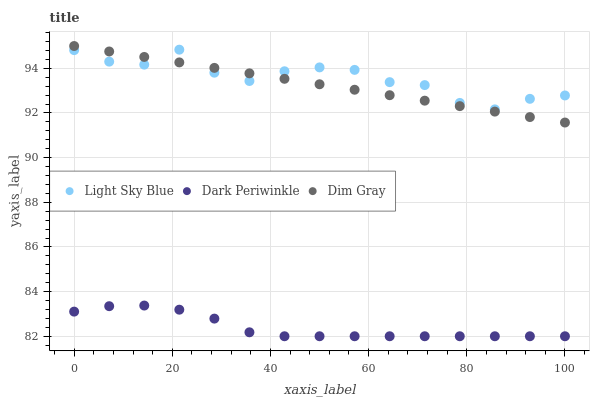Does Dark Periwinkle have the minimum area under the curve?
Answer yes or no. Yes. Does Light Sky Blue have the maximum area under the curve?
Answer yes or no. Yes. Does Light Sky Blue have the minimum area under the curve?
Answer yes or no. No. Does Dark Periwinkle have the maximum area under the curve?
Answer yes or no. No. Is Dim Gray the smoothest?
Answer yes or no. Yes. Is Light Sky Blue the roughest?
Answer yes or no. Yes. Is Dark Periwinkle the smoothest?
Answer yes or no. No. Is Dark Periwinkle the roughest?
Answer yes or no. No. Does Dark Periwinkle have the lowest value?
Answer yes or no. Yes. Does Light Sky Blue have the lowest value?
Answer yes or no. No. Does Dim Gray have the highest value?
Answer yes or no. Yes. Does Light Sky Blue have the highest value?
Answer yes or no. No. Is Dark Periwinkle less than Light Sky Blue?
Answer yes or no. Yes. Is Light Sky Blue greater than Dark Periwinkle?
Answer yes or no. Yes. Does Dim Gray intersect Light Sky Blue?
Answer yes or no. Yes. Is Dim Gray less than Light Sky Blue?
Answer yes or no. No. Is Dim Gray greater than Light Sky Blue?
Answer yes or no. No. Does Dark Periwinkle intersect Light Sky Blue?
Answer yes or no. No. 